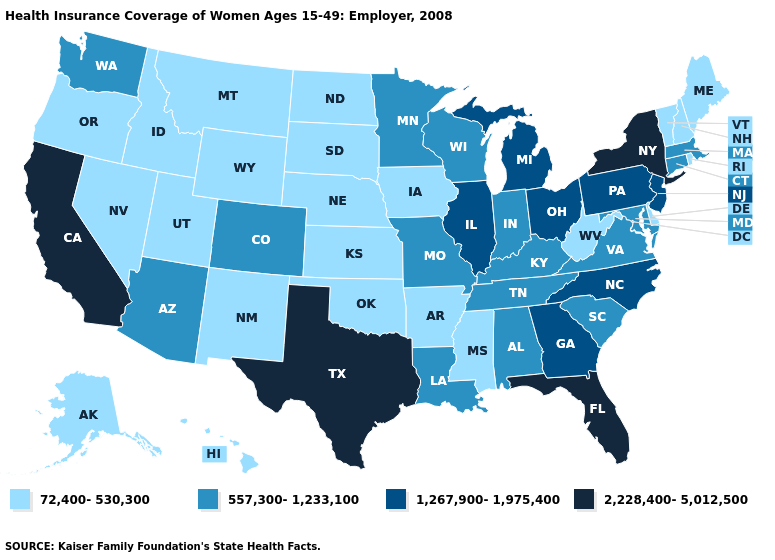Is the legend a continuous bar?
Quick response, please. No. What is the value of Alabama?
Keep it brief. 557,300-1,233,100. What is the value of Missouri?
Quick response, please. 557,300-1,233,100. Does California have the highest value in the West?
Write a very short answer. Yes. What is the lowest value in the West?
Concise answer only. 72,400-530,300. What is the value of Pennsylvania?
Be succinct. 1,267,900-1,975,400. What is the value of Florida?
Answer briefly. 2,228,400-5,012,500. Does New York have the highest value in the Northeast?
Concise answer only. Yes. Does the map have missing data?
Be succinct. No. Does Arkansas have the lowest value in the South?
Answer briefly. Yes. Does Arkansas have the lowest value in the South?
Concise answer only. Yes. Which states hav the highest value in the MidWest?
Answer briefly. Illinois, Michigan, Ohio. What is the lowest value in the USA?
Short answer required. 72,400-530,300. What is the value of Pennsylvania?
Be succinct. 1,267,900-1,975,400. What is the value of Alaska?
Quick response, please. 72,400-530,300. 